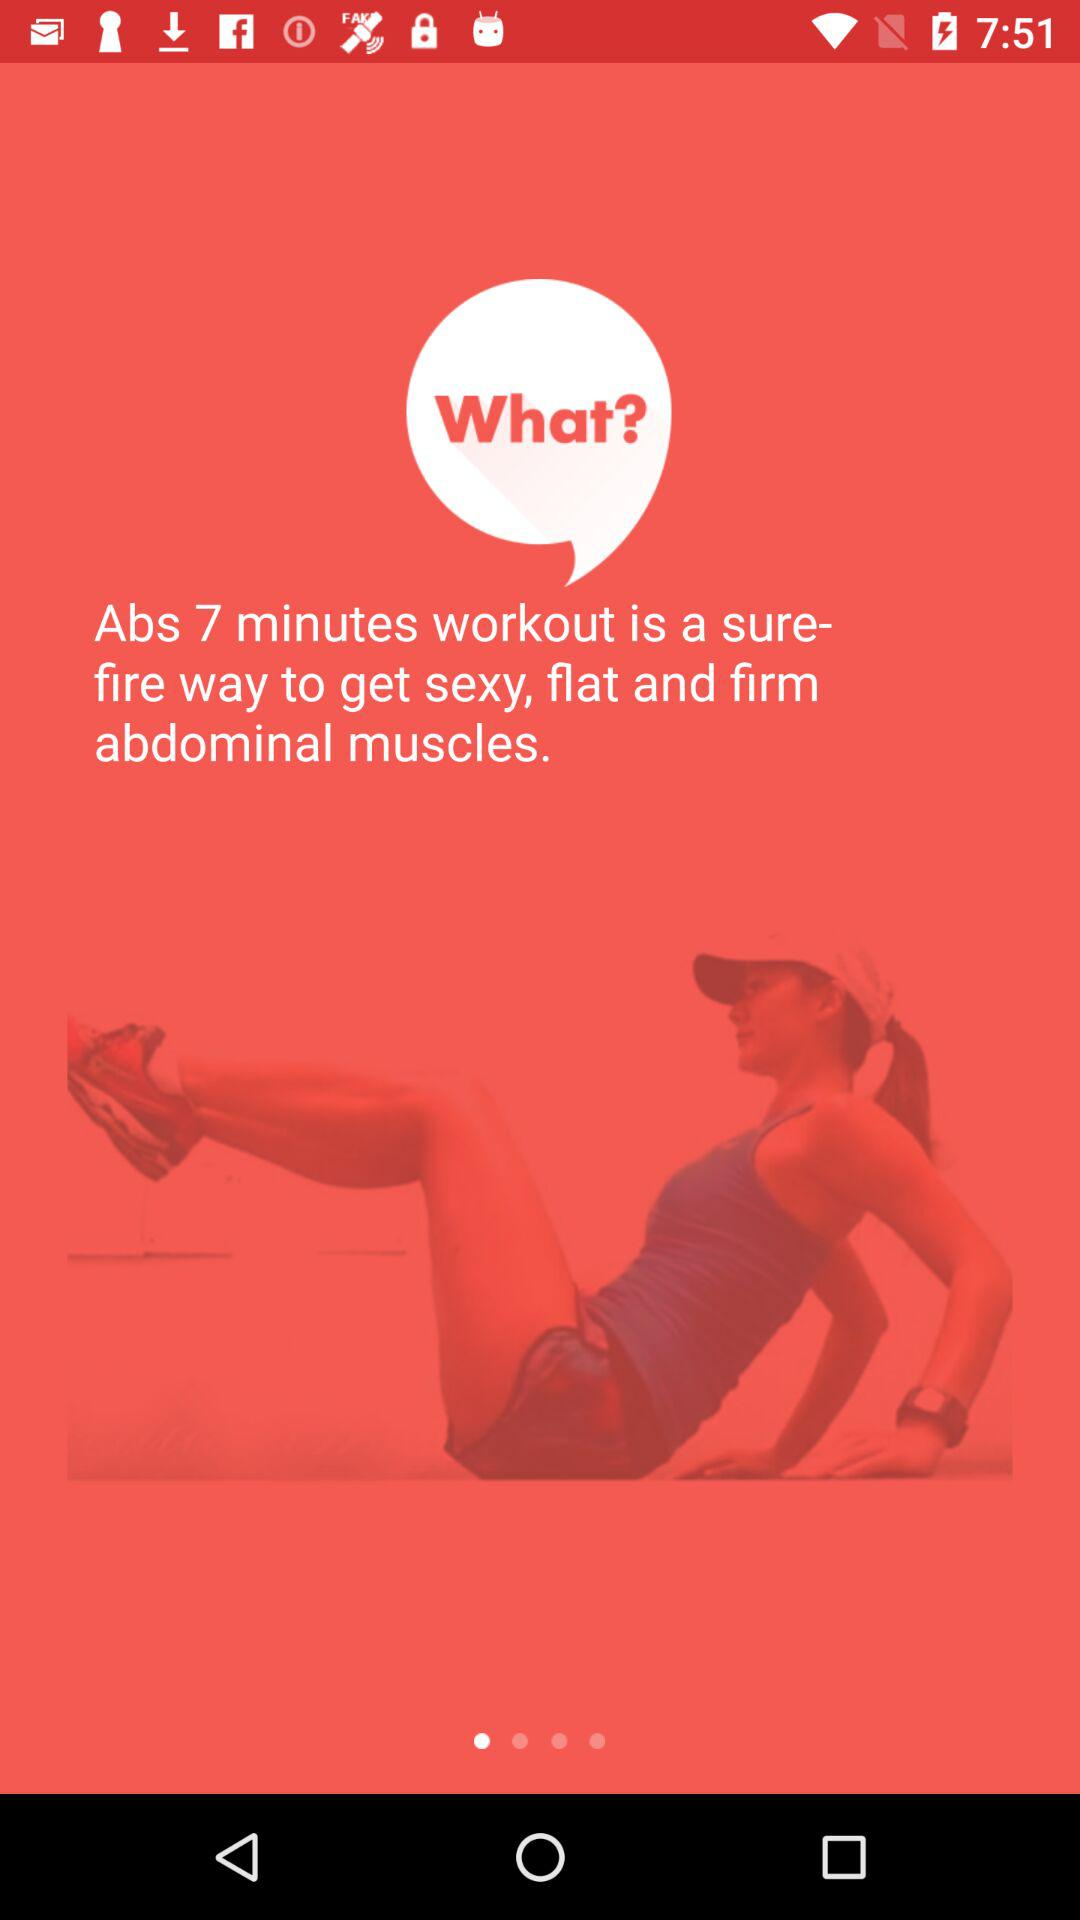What is the time duration of the "Abs workout"? The time duration is 7 minutes. 